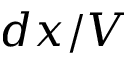<formula> <loc_0><loc_0><loc_500><loc_500>d x / V</formula> 